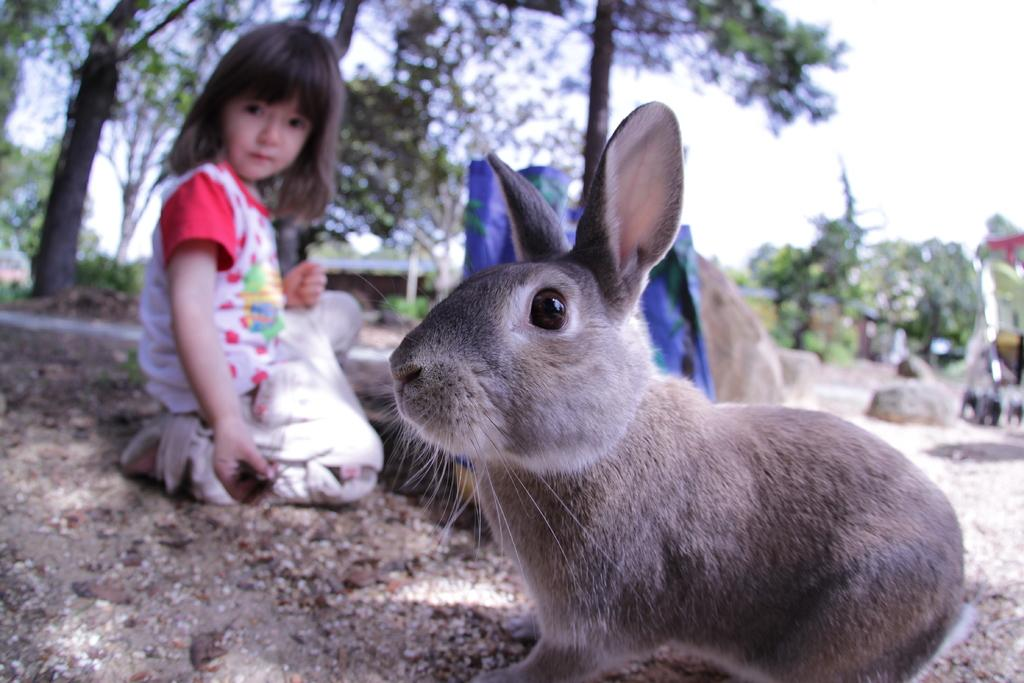Who is the main subject in the image? There is a girl in the image. What animal is present in the image? There is a rabbit in the front of the image. What type of natural environment is visible in the image set in? There are many trees in the background of the image, suggesting a forest or wooded area. What is visible at the bottom of the image? There is ground visible at the bottom of the image. What type of industry can be seen in the background of the image? There is no industry present in the image; it features a girl and a rabbit in a natural environment with trees in the background. 